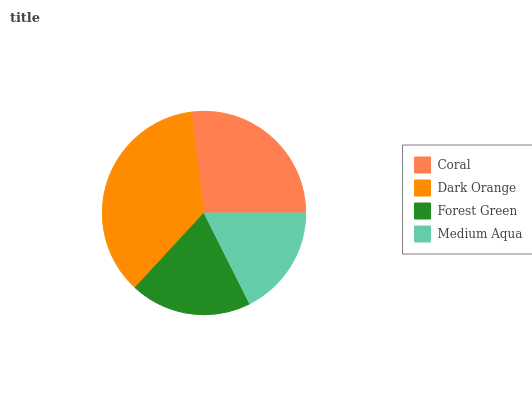Is Medium Aqua the minimum?
Answer yes or no. Yes. Is Dark Orange the maximum?
Answer yes or no. Yes. Is Forest Green the minimum?
Answer yes or no. No. Is Forest Green the maximum?
Answer yes or no. No. Is Dark Orange greater than Forest Green?
Answer yes or no. Yes. Is Forest Green less than Dark Orange?
Answer yes or no. Yes. Is Forest Green greater than Dark Orange?
Answer yes or no. No. Is Dark Orange less than Forest Green?
Answer yes or no. No. Is Coral the high median?
Answer yes or no. Yes. Is Forest Green the low median?
Answer yes or no. Yes. Is Forest Green the high median?
Answer yes or no. No. Is Medium Aqua the low median?
Answer yes or no. No. 